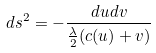<formula> <loc_0><loc_0><loc_500><loc_500>d s ^ { 2 } = - \frac { d u d v } { \frac { \lambda } { 2 } ( c ( u ) + v ) }</formula> 